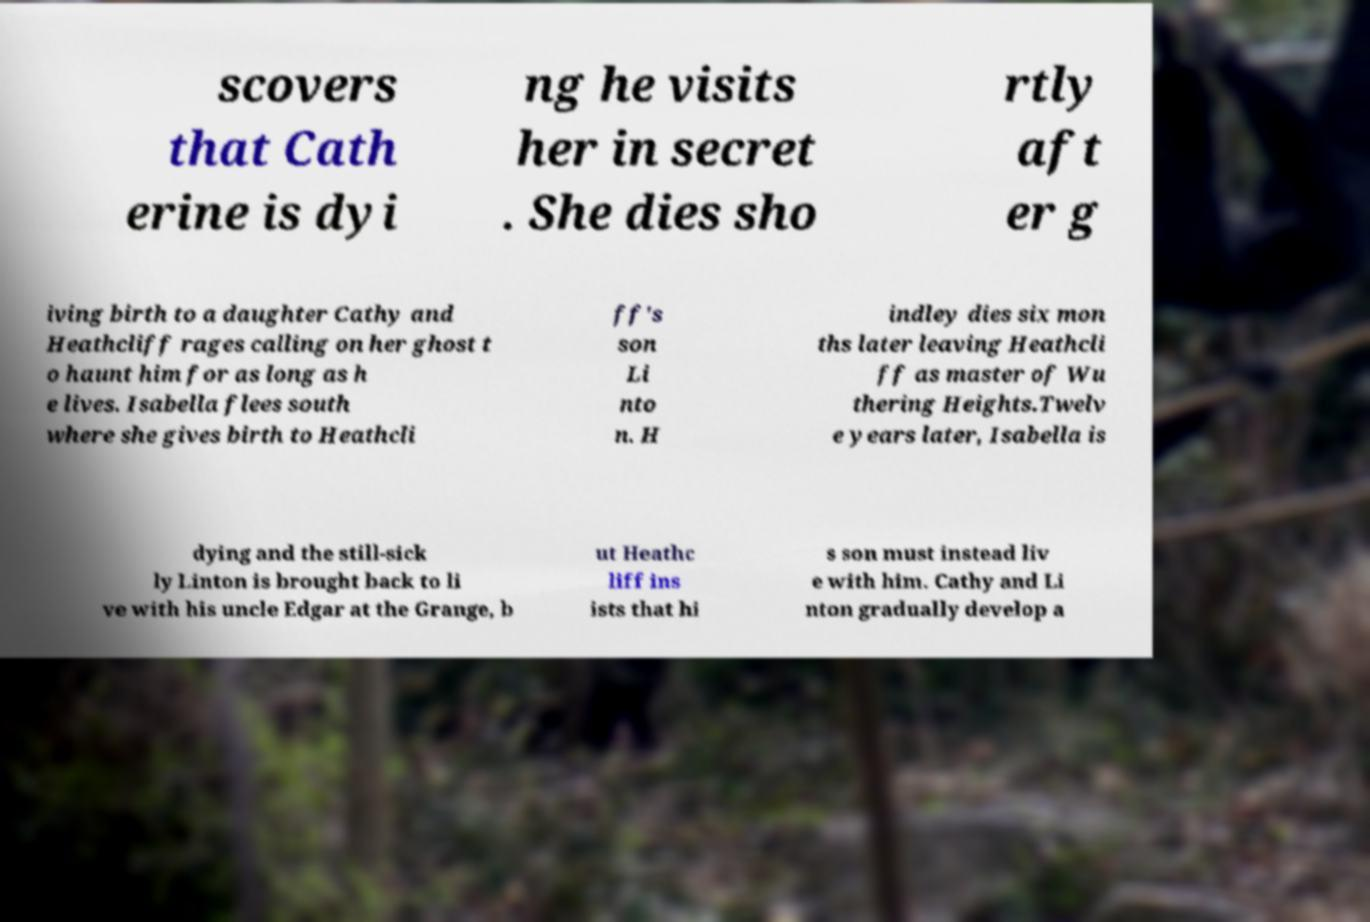Can you read and provide the text displayed in the image?This photo seems to have some interesting text. Can you extract and type it out for me? scovers that Cath erine is dyi ng he visits her in secret . She dies sho rtly aft er g iving birth to a daughter Cathy and Heathcliff rages calling on her ghost t o haunt him for as long as h e lives. Isabella flees south where she gives birth to Heathcli ff's son Li nto n. H indley dies six mon ths later leaving Heathcli ff as master of Wu thering Heights.Twelv e years later, Isabella is dying and the still-sick ly Linton is brought back to li ve with his uncle Edgar at the Grange, b ut Heathc liff ins ists that hi s son must instead liv e with him. Cathy and Li nton gradually develop a 